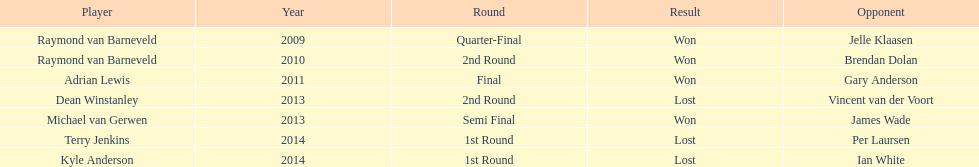Who are the only players listed that played in 2011? Adrian Lewis. 